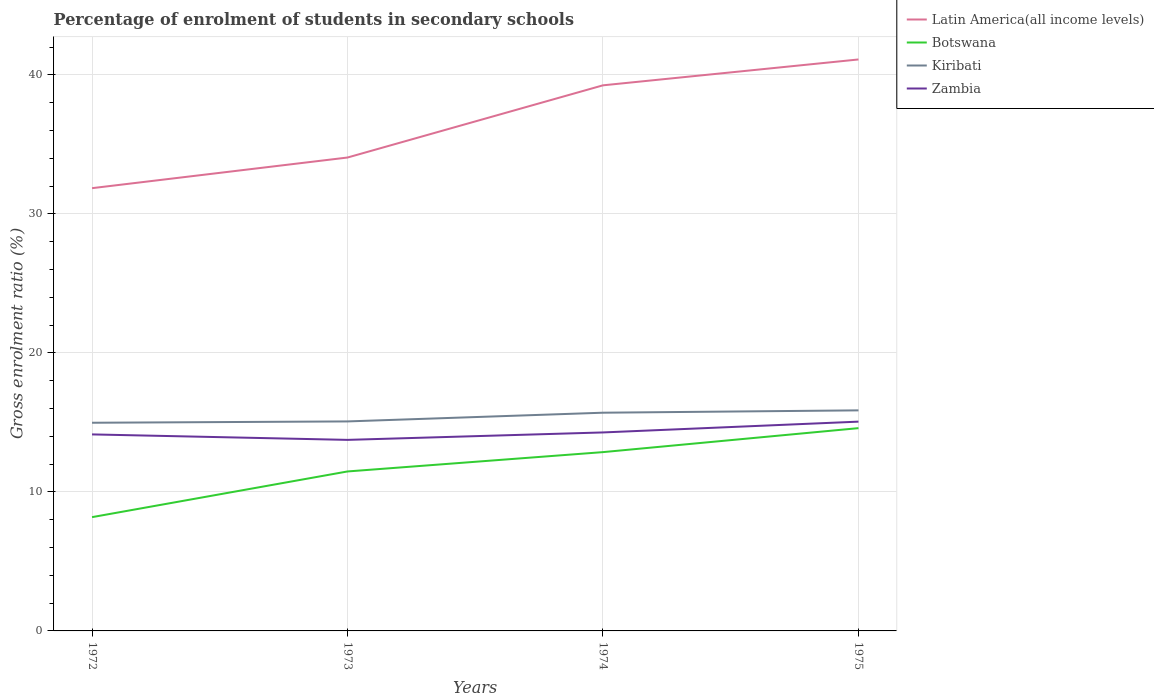How many different coloured lines are there?
Your answer should be very brief. 4. Does the line corresponding to Botswana intersect with the line corresponding to Latin America(all income levels)?
Keep it short and to the point. No. Is the number of lines equal to the number of legend labels?
Your answer should be compact. Yes. Across all years, what is the maximum percentage of students enrolled in secondary schools in Botswana?
Provide a succinct answer. 8.18. In which year was the percentage of students enrolled in secondary schools in Botswana maximum?
Ensure brevity in your answer.  1972. What is the total percentage of students enrolled in secondary schools in Latin America(all income levels) in the graph?
Provide a succinct answer. -9.26. What is the difference between the highest and the second highest percentage of students enrolled in secondary schools in Kiribati?
Offer a terse response. 0.89. How many lines are there?
Keep it short and to the point. 4. What is the difference between two consecutive major ticks on the Y-axis?
Your response must be concise. 10. Are the values on the major ticks of Y-axis written in scientific E-notation?
Provide a short and direct response. No. Does the graph contain grids?
Provide a short and direct response. Yes. Where does the legend appear in the graph?
Your answer should be very brief. Top right. What is the title of the graph?
Keep it short and to the point. Percentage of enrolment of students in secondary schools. What is the Gross enrolment ratio (%) of Latin America(all income levels) in 1972?
Keep it short and to the point. 31.85. What is the Gross enrolment ratio (%) of Botswana in 1972?
Offer a very short reply. 8.18. What is the Gross enrolment ratio (%) of Kiribati in 1972?
Your answer should be very brief. 14.97. What is the Gross enrolment ratio (%) in Zambia in 1972?
Provide a short and direct response. 14.14. What is the Gross enrolment ratio (%) of Latin America(all income levels) in 1973?
Your answer should be very brief. 34.05. What is the Gross enrolment ratio (%) of Botswana in 1973?
Keep it short and to the point. 11.47. What is the Gross enrolment ratio (%) of Kiribati in 1973?
Make the answer very short. 15.07. What is the Gross enrolment ratio (%) of Zambia in 1973?
Keep it short and to the point. 13.74. What is the Gross enrolment ratio (%) in Latin America(all income levels) in 1974?
Provide a short and direct response. 39.25. What is the Gross enrolment ratio (%) in Botswana in 1974?
Keep it short and to the point. 12.86. What is the Gross enrolment ratio (%) in Kiribati in 1974?
Make the answer very short. 15.7. What is the Gross enrolment ratio (%) of Zambia in 1974?
Your answer should be compact. 14.28. What is the Gross enrolment ratio (%) of Latin America(all income levels) in 1975?
Provide a succinct answer. 41.11. What is the Gross enrolment ratio (%) in Botswana in 1975?
Keep it short and to the point. 14.59. What is the Gross enrolment ratio (%) in Kiribati in 1975?
Keep it short and to the point. 15.87. What is the Gross enrolment ratio (%) of Zambia in 1975?
Provide a short and direct response. 15.05. Across all years, what is the maximum Gross enrolment ratio (%) in Latin America(all income levels)?
Offer a very short reply. 41.11. Across all years, what is the maximum Gross enrolment ratio (%) of Botswana?
Provide a succinct answer. 14.59. Across all years, what is the maximum Gross enrolment ratio (%) in Kiribati?
Your response must be concise. 15.87. Across all years, what is the maximum Gross enrolment ratio (%) in Zambia?
Provide a succinct answer. 15.05. Across all years, what is the minimum Gross enrolment ratio (%) of Latin America(all income levels)?
Provide a short and direct response. 31.85. Across all years, what is the minimum Gross enrolment ratio (%) of Botswana?
Ensure brevity in your answer.  8.18. Across all years, what is the minimum Gross enrolment ratio (%) in Kiribati?
Offer a very short reply. 14.97. Across all years, what is the minimum Gross enrolment ratio (%) in Zambia?
Your answer should be very brief. 13.74. What is the total Gross enrolment ratio (%) in Latin America(all income levels) in the graph?
Keep it short and to the point. 146.26. What is the total Gross enrolment ratio (%) in Botswana in the graph?
Provide a succinct answer. 47.1. What is the total Gross enrolment ratio (%) in Kiribati in the graph?
Provide a short and direct response. 61.61. What is the total Gross enrolment ratio (%) in Zambia in the graph?
Your response must be concise. 57.21. What is the difference between the Gross enrolment ratio (%) of Latin America(all income levels) in 1972 and that in 1973?
Your answer should be very brief. -2.2. What is the difference between the Gross enrolment ratio (%) of Botswana in 1972 and that in 1973?
Offer a terse response. -3.29. What is the difference between the Gross enrolment ratio (%) in Kiribati in 1972 and that in 1973?
Give a very brief answer. -0.1. What is the difference between the Gross enrolment ratio (%) in Zambia in 1972 and that in 1973?
Give a very brief answer. 0.39. What is the difference between the Gross enrolment ratio (%) of Latin America(all income levels) in 1972 and that in 1974?
Make the answer very short. -7.4. What is the difference between the Gross enrolment ratio (%) of Botswana in 1972 and that in 1974?
Provide a succinct answer. -4.68. What is the difference between the Gross enrolment ratio (%) in Kiribati in 1972 and that in 1974?
Your answer should be very brief. -0.72. What is the difference between the Gross enrolment ratio (%) in Zambia in 1972 and that in 1974?
Give a very brief answer. -0.14. What is the difference between the Gross enrolment ratio (%) in Latin America(all income levels) in 1972 and that in 1975?
Offer a terse response. -9.26. What is the difference between the Gross enrolment ratio (%) of Botswana in 1972 and that in 1975?
Offer a very short reply. -6.4. What is the difference between the Gross enrolment ratio (%) in Kiribati in 1972 and that in 1975?
Provide a short and direct response. -0.89. What is the difference between the Gross enrolment ratio (%) of Zambia in 1972 and that in 1975?
Give a very brief answer. -0.92. What is the difference between the Gross enrolment ratio (%) of Latin America(all income levels) in 1973 and that in 1974?
Offer a terse response. -5.19. What is the difference between the Gross enrolment ratio (%) of Botswana in 1973 and that in 1974?
Your response must be concise. -1.39. What is the difference between the Gross enrolment ratio (%) in Kiribati in 1973 and that in 1974?
Provide a short and direct response. -0.63. What is the difference between the Gross enrolment ratio (%) of Zambia in 1973 and that in 1974?
Your answer should be very brief. -0.54. What is the difference between the Gross enrolment ratio (%) in Latin America(all income levels) in 1973 and that in 1975?
Your answer should be compact. -7.05. What is the difference between the Gross enrolment ratio (%) in Botswana in 1973 and that in 1975?
Make the answer very short. -3.12. What is the difference between the Gross enrolment ratio (%) of Kiribati in 1973 and that in 1975?
Your response must be concise. -0.8. What is the difference between the Gross enrolment ratio (%) in Zambia in 1973 and that in 1975?
Offer a very short reply. -1.31. What is the difference between the Gross enrolment ratio (%) of Latin America(all income levels) in 1974 and that in 1975?
Ensure brevity in your answer.  -1.86. What is the difference between the Gross enrolment ratio (%) in Botswana in 1974 and that in 1975?
Your response must be concise. -1.72. What is the difference between the Gross enrolment ratio (%) of Kiribati in 1974 and that in 1975?
Offer a terse response. -0.17. What is the difference between the Gross enrolment ratio (%) of Zambia in 1974 and that in 1975?
Your response must be concise. -0.78. What is the difference between the Gross enrolment ratio (%) of Latin America(all income levels) in 1972 and the Gross enrolment ratio (%) of Botswana in 1973?
Provide a succinct answer. 20.38. What is the difference between the Gross enrolment ratio (%) in Latin America(all income levels) in 1972 and the Gross enrolment ratio (%) in Kiribati in 1973?
Ensure brevity in your answer.  16.78. What is the difference between the Gross enrolment ratio (%) in Latin America(all income levels) in 1972 and the Gross enrolment ratio (%) in Zambia in 1973?
Ensure brevity in your answer.  18.11. What is the difference between the Gross enrolment ratio (%) of Botswana in 1972 and the Gross enrolment ratio (%) of Kiribati in 1973?
Make the answer very short. -6.89. What is the difference between the Gross enrolment ratio (%) in Botswana in 1972 and the Gross enrolment ratio (%) in Zambia in 1973?
Give a very brief answer. -5.56. What is the difference between the Gross enrolment ratio (%) of Kiribati in 1972 and the Gross enrolment ratio (%) of Zambia in 1973?
Provide a short and direct response. 1.23. What is the difference between the Gross enrolment ratio (%) in Latin America(all income levels) in 1972 and the Gross enrolment ratio (%) in Botswana in 1974?
Provide a succinct answer. 18.99. What is the difference between the Gross enrolment ratio (%) of Latin America(all income levels) in 1972 and the Gross enrolment ratio (%) of Kiribati in 1974?
Your answer should be very brief. 16.15. What is the difference between the Gross enrolment ratio (%) in Latin America(all income levels) in 1972 and the Gross enrolment ratio (%) in Zambia in 1974?
Your answer should be compact. 17.57. What is the difference between the Gross enrolment ratio (%) of Botswana in 1972 and the Gross enrolment ratio (%) of Kiribati in 1974?
Ensure brevity in your answer.  -7.51. What is the difference between the Gross enrolment ratio (%) in Botswana in 1972 and the Gross enrolment ratio (%) in Zambia in 1974?
Your response must be concise. -6.09. What is the difference between the Gross enrolment ratio (%) in Kiribati in 1972 and the Gross enrolment ratio (%) in Zambia in 1974?
Keep it short and to the point. 0.7. What is the difference between the Gross enrolment ratio (%) in Latin America(all income levels) in 1972 and the Gross enrolment ratio (%) in Botswana in 1975?
Make the answer very short. 17.26. What is the difference between the Gross enrolment ratio (%) of Latin America(all income levels) in 1972 and the Gross enrolment ratio (%) of Kiribati in 1975?
Keep it short and to the point. 15.98. What is the difference between the Gross enrolment ratio (%) in Latin America(all income levels) in 1972 and the Gross enrolment ratio (%) in Zambia in 1975?
Offer a very short reply. 16.79. What is the difference between the Gross enrolment ratio (%) of Botswana in 1972 and the Gross enrolment ratio (%) of Kiribati in 1975?
Make the answer very short. -7.68. What is the difference between the Gross enrolment ratio (%) in Botswana in 1972 and the Gross enrolment ratio (%) in Zambia in 1975?
Make the answer very short. -6.87. What is the difference between the Gross enrolment ratio (%) of Kiribati in 1972 and the Gross enrolment ratio (%) of Zambia in 1975?
Provide a short and direct response. -0.08. What is the difference between the Gross enrolment ratio (%) of Latin America(all income levels) in 1973 and the Gross enrolment ratio (%) of Botswana in 1974?
Offer a very short reply. 21.19. What is the difference between the Gross enrolment ratio (%) of Latin America(all income levels) in 1973 and the Gross enrolment ratio (%) of Kiribati in 1974?
Ensure brevity in your answer.  18.36. What is the difference between the Gross enrolment ratio (%) in Latin America(all income levels) in 1973 and the Gross enrolment ratio (%) in Zambia in 1974?
Offer a very short reply. 19.78. What is the difference between the Gross enrolment ratio (%) of Botswana in 1973 and the Gross enrolment ratio (%) of Kiribati in 1974?
Give a very brief answer. -4.23. What is the difference between the Gross enrolment ratio (%) of Botswana in 1973 and the Gross enrolment ratio (%) of Zambia in 1974?
Provide a succinct answer. -2.81. What is the difference between the Gross enrolment ratio (%) in Kiribati in 1973 and the Gross enrolment ratio (%) in Zambia in 1974?
Make the answer very short. 0.79. What is the difference between the Gross enrolment ratio (%) of Latin America(all income levels) in 1973 and the Gross enrolment ratio (%) of Botswana in 1975?
Provide a succinct answer. 19.47. What is the difference between the Gross enrolment ratio (%) of Latin America(all income levels) in 1973 and the Gross enrolment ratio (%) of Kiribati in 1975?
Offer a very short reply. 18.19. What is the difference between the Gross enrolment ratio (%) in Latin America(all income levels) in 1973 and the Gross enrolment ratio (%) in Zambia in 1975?
Offer a terse response. 19. What is the difference between the Gross enrolment ratio (%) in Botswana in 1973 and the Gross enrolment ratio (%) in Kiribati in 1975?
Give a very brief answer. -4.4. What is the difference between the Gross enrolment ratio (%) of Botswana in 1973 and the Gross enrolment ratio (%) of Zambia in 1975?
Ensure brevity in your answer.  -3.58. What is the difference between the Gross enrolment ratio (%) in Kiribati in 1973 and the Gross enrolment ratio (%) in Zambia in 1975?
Offer a very short reply. 0.02. What is the difference between the Gross enrolment ratio (%) of Latin America(all income levels) in 1974 and the Gross enrolment ratio (%) of Botswana in 1975?
Keep it short and to the point. 24.66. What is the difference between the Gross enrolment ratio (%) of Latin America(all income levels) in 1974 and the Gross enrolment ratio (%) of Kiribati in 1975?
Provide a succinct answer. 23.38. What is the difference between the Gross enrolment ratio (%) of Latin America(all income levels) in 1974 and the Gross enrolment ratio (%) of Zambia in 1975?
Provide a succinct answer. 24.19. What is the difference between the Gross enrolment ratio (%) of Botswana in 1974 and the Gross enrolment ratio (%) of Kiribati in 1975?
Ensure brevity in your answer.  -3. What is the difference between the Gross enrolment ratio (%) in Botswana in 1974 and the Gross enrolment ratio (%) in Zambia in 1975?
Make the answer very short. -2.19. What is the difference between the Gross enrolment ratio (%) of Kiribati in 1974 and the Gross enrolment ratio (%) of Zambia in 1975?
Your response must be concise. 0.64. What is the average Gross enrolment ratio (%) in Latin America(all income levels) per year?
Offer a very short reply. 36.56. What is the average Gross enrolment ratio (%) in Botswana per year?
Your answer should be very brief. 11.78. What is the average Gross enrolment ratio (%) in Kiribati per year?
Ensure brevity in your answer.  15.4. What is the average Gross enrolment ratio (%) of Zambia per year?
Make the answer very short. 14.3. In the year 1972, what is the difference between the Gross enrolment ratio (%) of Latin America(all income levels) and Gross enrolment ratio (%) of Botswana?
Offer a terse response. 23.66. In the year 1972, what is the difference between the Gross enrolment ratio (%) of Latin America(all income levels) and Gross enrolment ratio (%) of Kiribati?
Your response must be concise. 16.88. In the year 1972, what is the difference between the Gross enrolment ratio (%) of Latin America(all income levels) and Gross enrolment ratio (%) of Zambia?
Your answer should be very brief. 17.71. In the year 1972, what is the difference between the Gross enrolment ratio (%) of Botswana and Gross enrolment ratio (%) of Kiribati?
Make the answer very short. -6.79. In the year 1972, what is the difference between the Gross enrolment ratio (%) of Botswana and Gross enrolment ratio (%) of Zambia?
Your response must be concise. -5.95. In the year 1972, what is the difference between the Gross enrolment ratio (%) in Kiribati and Gross enrolment ratio (%) in Zambia?
Provide a succinct answer. 0.84. In the year 1973, what is the difference between the Gross enrolment ratio (%) of Latin America(all income levels) and Gross enrolment ratio (%) of Botswana?
Keep it short and to the point. 22.58. In the year 1973, what is the difference between the Gross enrolment ratio (%) of Latin America(all income levels) and Gross enrolment ratio (%) of Kiribati?
Your answer should be compact. 18.98. In the year 1973, what is the difference between the Gross enrolment ratio (%) in Latin America(all income levels) and Gross enrolment ratio (%) in Zambia?
Your answer should be compact. 20.31. In the year 1973, what is the difference between the Gross enrolment ratio (%) of Botswana and Gross enrolment ratio (%) of Kiribati?
Give a very brief answer. -3.6. In the year 1973, what is the difference between the Gross enrolment ratio (%) in Botswana and Gross enrolment ratio (%) in Zambia?
Your answer should be compact. -2.27. In the year 1973, what is the difference between the Gross enrolment ratio (%) in Kiribati and Gross enrolment ratio (%) in Zambia?
Your answer should be compact. 1.33. In the year 1974, what is the difference between the Gross enrolment ratio (%) of Latin America(all income levels) and Gross enrolment ratio (%) of Botswana?
Provide a succinct answer. 26.39. In the year 1974, what is the difference between the Gross enrolment ratio (%) of Latin America(all income levels) and Gross enrolment ratio (%) of Kiribati?
Provide a succinct answer. 23.55. In the year 1974, what is the difference between the Gross enrolment ratio (%) of Latin America(all income levels) and Gross enrolment ratio (%) of Zambia?
Offer a very short reply. 24.97. In the year 1974, what is the difference between the Gross enrolment ratio (%) of Botswana and Gross enrolment ratio (%) of Kiribati?
Your response must be concise. -2.84. In the year 1974, what is the difference between the Gross enrolment ratio (%) of Botswana and Gross enrolment ratio (%) of Zambia?
Give a very brief answer. -1.42. In the year 1974, what is the difference between the Gross enrolment ratio (%) of Kiribati and Gross enrolment ratio (%) of Zambia?
Offer a terse response. 1.42. In the year 1975, what is the difference between the Gross enrolment ratio (%) of Latin America(all income levels) and Gross enrolment ratio (%) of Botswana?
Give a very brief answer. 26.52. In the year 1975, what is the difference between the Gross enrolment ratio (%) in Latin America(all income levels) and Gross enrolment ratio (%) in Kiribati?
Make the answer very short. 25.24. In the year 1975, what is the difference between the Gross enrolment ratio (%) in Latin America(all income levels) and Gross enrolment ratio (%) in Zambia?
Make the answer very short. 26.05. In the year 1975, what is the difference between the Gross enrolment ratio (%) in Botswana and Gross enrolment ratio (%) in Kiribati?
Ensure brevity in your answer.  -1.28. In the year 1975, what is the difference between the Gross enrolment ratio (%) in Botswana and Gross enrolment ratio (%) in Zambia?
Give a very brief answer. -0.47. In the year 1975, what is the difference between the Gross enrolment ratio (%) in Kiribati and Gross enrolment ratio (%) in Zambia?
Give a very brief answer. 0.81. What is the ratio of the Gross enrolment ratio (%) of Latin America(all income levels) in 1972 to that in 1973?
Provide a short and direct response. 0.94. What is the ratio of the Gross enrolment ratio (%) in Botswana in 1972 to that in 1973?
Make the answer very short. 0.71. What is the ratio of the Gross enrolment ratio (%) in Kiribati in 1972 to that in 1973?
Provide a short and direct response. 0.99. What is the ratio of the Gross enrolment ratio (%) of Zambia in 1972 to that in 1973?
Keep it short and to the point. 1.03. What is the ratio of the Gross enrolment ratio (%) in Latin America(all income levels) in 1972 to that in 1974?
Your response must be concise. 0.81. What is the ratio of the Gross enrolment ratio (%) in Botswana in 1972 to that in 1974?
Your response must be concise. 0.64. What is the ratio of the Gross enrolment ratio (%) of Kiribati in 1972 to that in 1974?
Ensure brevity in your answer.  0.95. What is the ratio of the Gross enrolment ratio (%) in Latin America(all income levels) in 1972 to that in 1975?
Offer a very short reply. 0.77. What is the ratio of the Gross enrolment ratio (%) of Botswana in 1972 to that in 1975?
Give a very brief answer. 0.56. What is the ratio of the Gross enrolment ratio (%) in Kiribati in 1972 to that in 1975?
Give a very brief answer. 0.94. What is the ratio of the Gross enrolment ratio (%) in Zambia in 1972 to that in 1975?
Provide a short and direct response. 0.94. What is the ratio of the Gross enrolment ratio (%) of Latin America(all income levels) in 1973 to that in 1974?
Your answer should be very brief. 0.87. What is the ratio of the Gross enrolment ratio (%) of Botswana in 1973 to that in 1974?
Offer a terse response. 0.89. What is the ratio of the Gross enrolment ratio (%) of Kiribati in 1973 to that in 1974?
Your answer should be compact. 0.96. What is the ratio of the Gross enrolment ratio (%) in Zambia in 1973 to that in 1974?
Your answer should be compact. 0.96. What is the ratio of the Gross enrolment ratio (%) of Latin America(all income levels) in 1973 to that in 1975?
Give a very brief answer. 0.83. What is the ratio of the Gross enrolment ratio (%) in Botswana in 1973 to that in 1975?
Your answer should be compact. 0.79. What is the ratio of the Gross enrolment ratio (%) in Kiribati in 1973 to that in 1975?
Offer a very short reply. 0.95. What is the ratio of the Gross enrolment ratio (%) in Zambia in 1973 to that in 1975?
Provide a short and direct response. 0.91. What is the ratio of the Gross enrolment ratio (%) in Latin America(all income levels) in 1974 to that in 1975?
Keep it short and to the point. 0.95. What is the ratio of the Gross enrolment ratio (%) of Botswana in 1974 to that in 1975?
Give a very brief answer. 0.88. What is the ratio of the Gross enrolment ratio (%) of Kiribati in 1974 to that in 1975?
Ensure brevity in your answer.  0.99. What is the ratio of the Gross enrolment ratio (%) in Zambia in 1974 to that in 1975?
Provide a succinct answer. 0.95. What is the difference between the highest and the second highest Gross enrolment ratio (%) of Latin America(all income levels)?
Your answer should be compact. 1.86. What is the difference between the highest and the second highest Gross enrolment ratio (%) in Botswana?
Give a very brief answer. 1.72. What is the difference between the highest and the second highest Gross enrolment ratio (%) in Kiribati?
Offer a very short reply. 0.17. What is the difference between the highest and the second highest Gross enrolment ratio (%) of Zambia?
Give a very brief answer. 0.78. What is the difference between the highest and the lowest Gross enrolment ratio (%) of Latin America(all income levels)?
Ensure brevity in your answer.  9.26. What is the difference between the highest and the lowest Gross enrolment ratio (%) in Botswana?
Offer a terse response. 6.4. What is the difference between the highest and the lowest Gross enrolment ratio (%) of Kiribati?
Your response must be concise. 0.89. What is the difference between the highest and the lowest Gross enrolment ratio (%) in Zambia?
Keep it short and to the point. 1.31. 